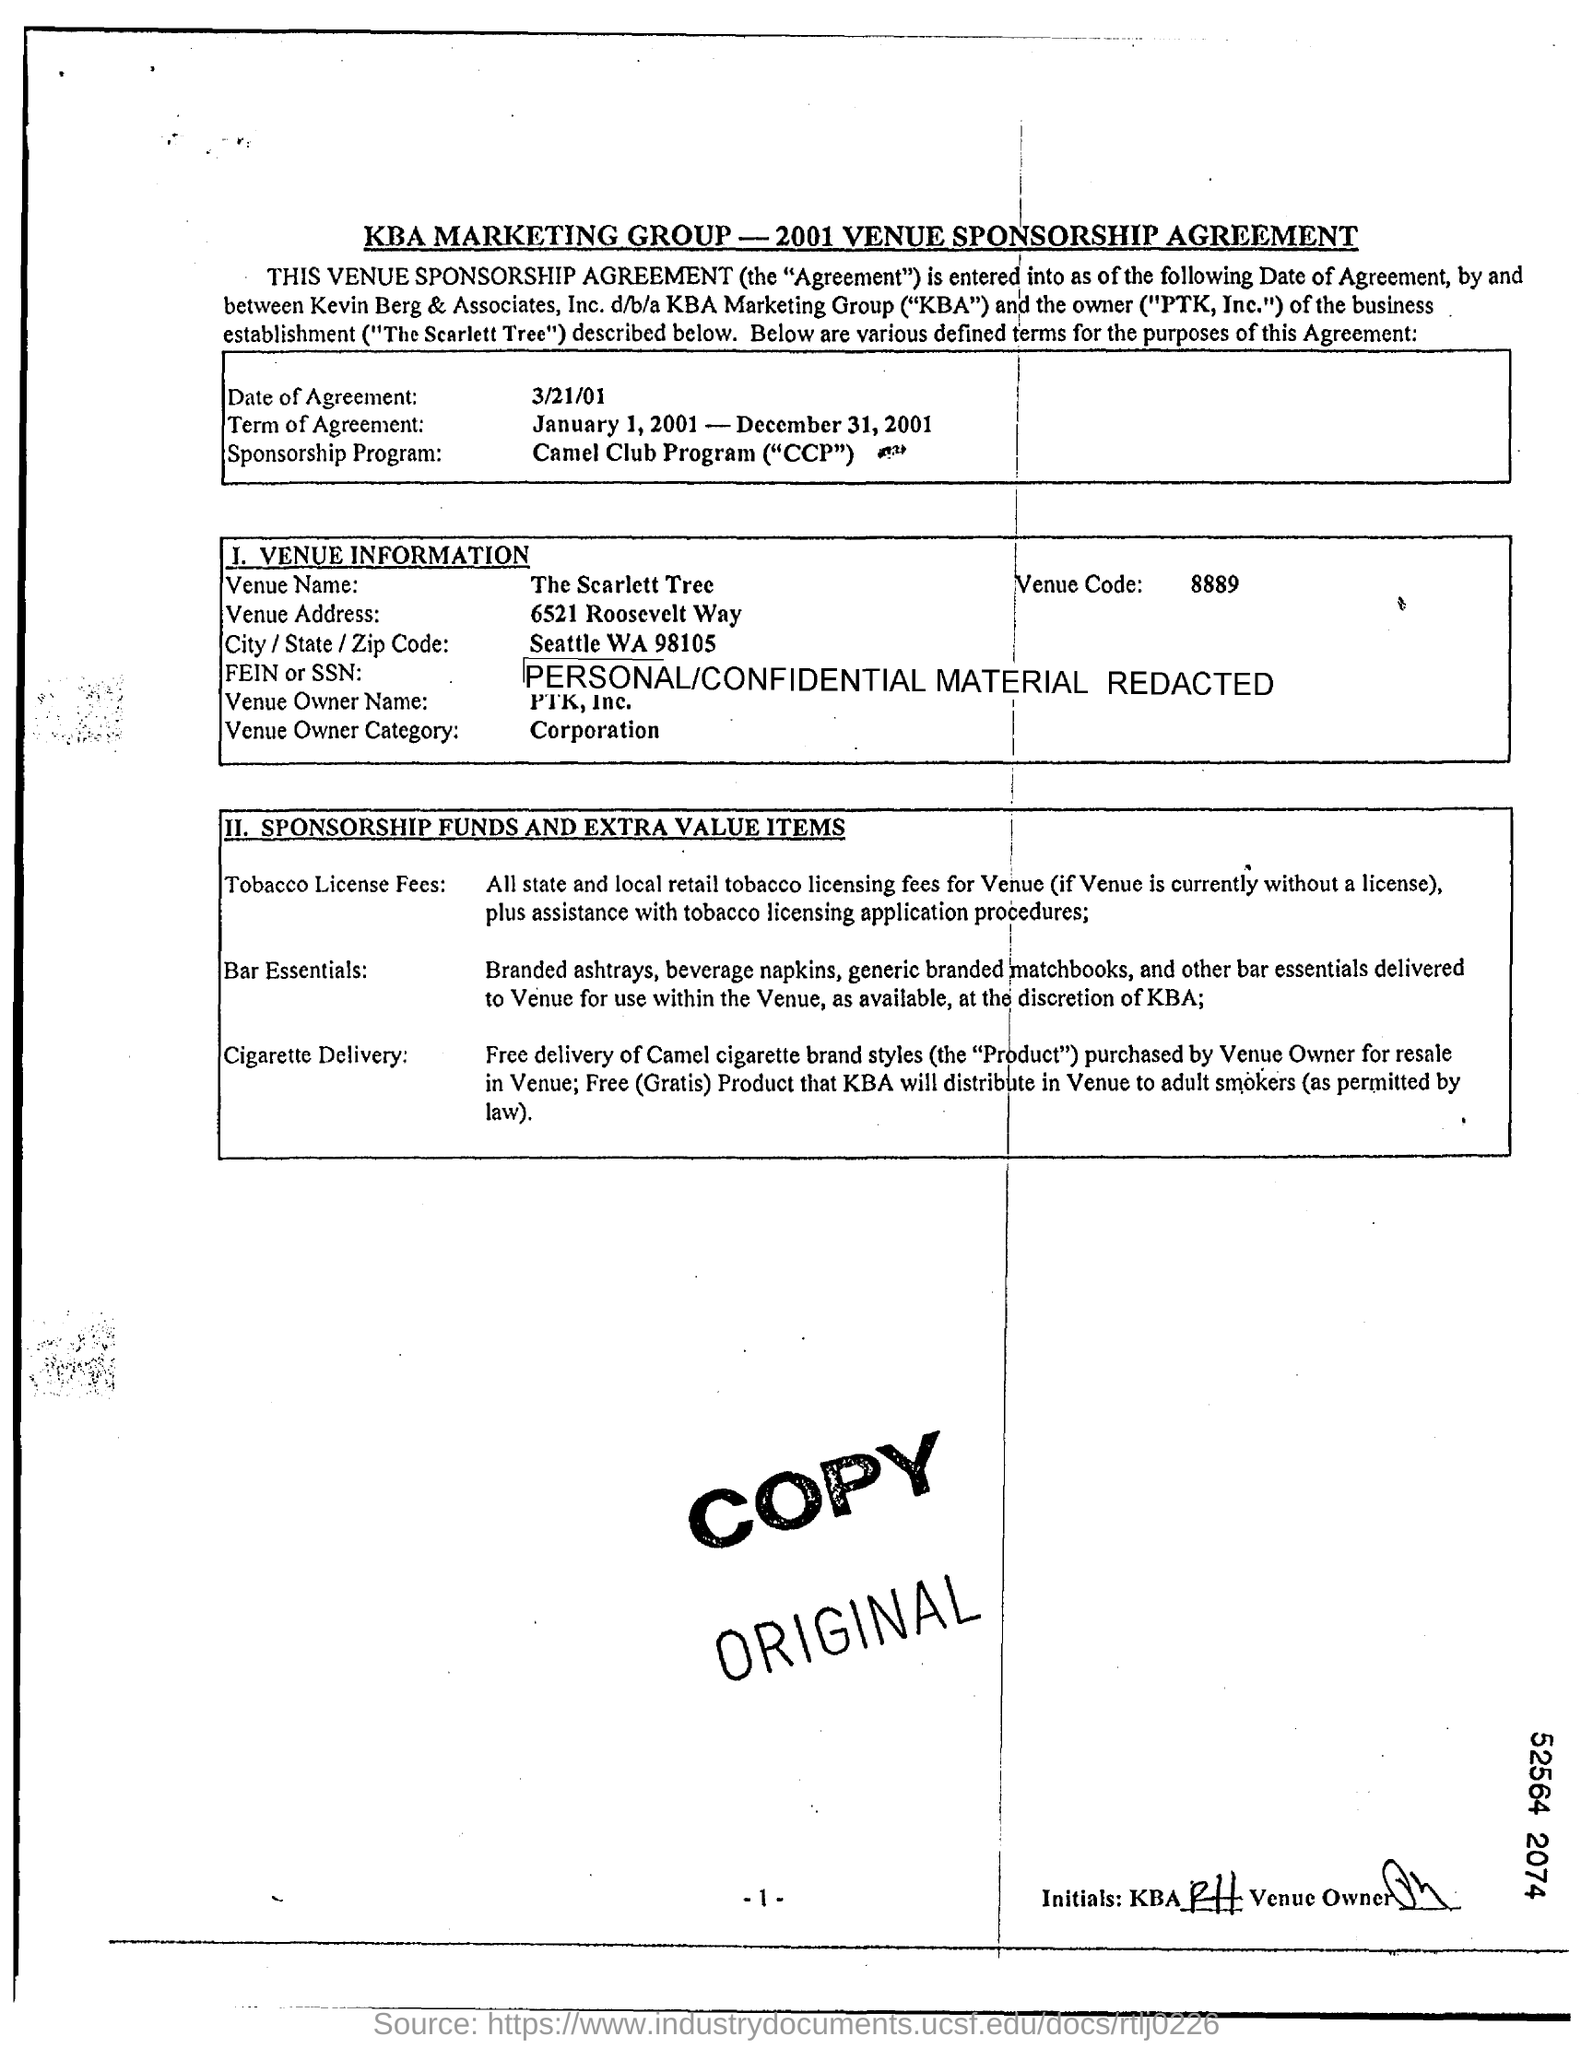List a handful of essential elements in this visual. The date of agreement is March 21, 2001. The Venue Address is located at 6521 Roosevelt Way. The Venue Owner category is designated for corporations. The Venue Name is The Scarlett Tree. 